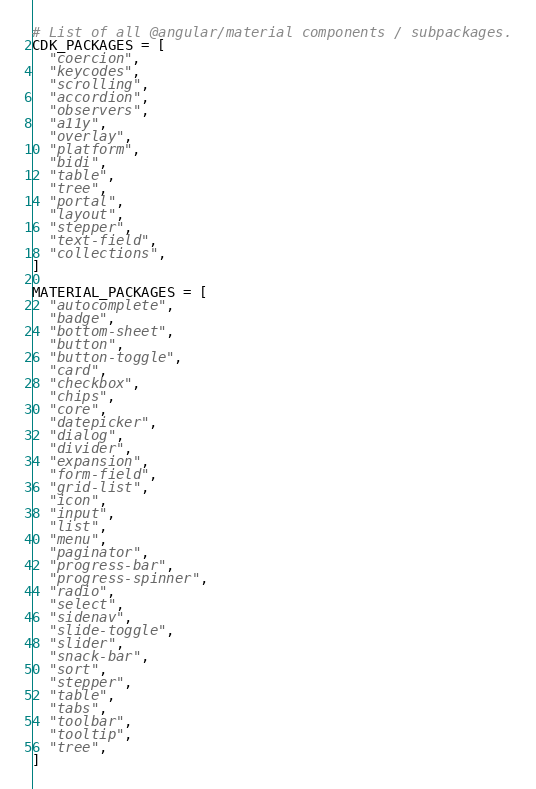<code> <loc_0><loc_0><loc_500><loc_500><_Python_># List of all @angular/material components / subpackages.
CDK_PACKAGES = [
  "coercion",
  "keycodes",
  "scrolling",
  "accordion",
  "observers",
  "a11y",
  "overlay",
  "platform",
  "bidi",
  "table",
  "tree",
  "portal",
  "layout",
  "stepper",
  "text-field",
  "collections",
]

MATERIAL_PACKAGES = [
  "autocomplete",
  "badge",
  "bottom-sheet",
  "button",
  "button-toggle",
  "card",
  "checkbox",
  "chips",
  "core",
  "datepicker",
  "dialog",
  "divider",
  "expansion",
  "form-field",
  "grid-list",
  "icon",
  "input",
  "list",
  "menu",
  "paginator",
  "progress-bar",
  "progress-spinner",
  "radio",
  "select",
  "sidenav",
  "slide-toggle",
  "slider",
  "snack-bar",
  "sort",
  "stepper",
  "table",
  "tabs",
  "toolbar",
  "tooltip",
  "tree",
]
</code> 